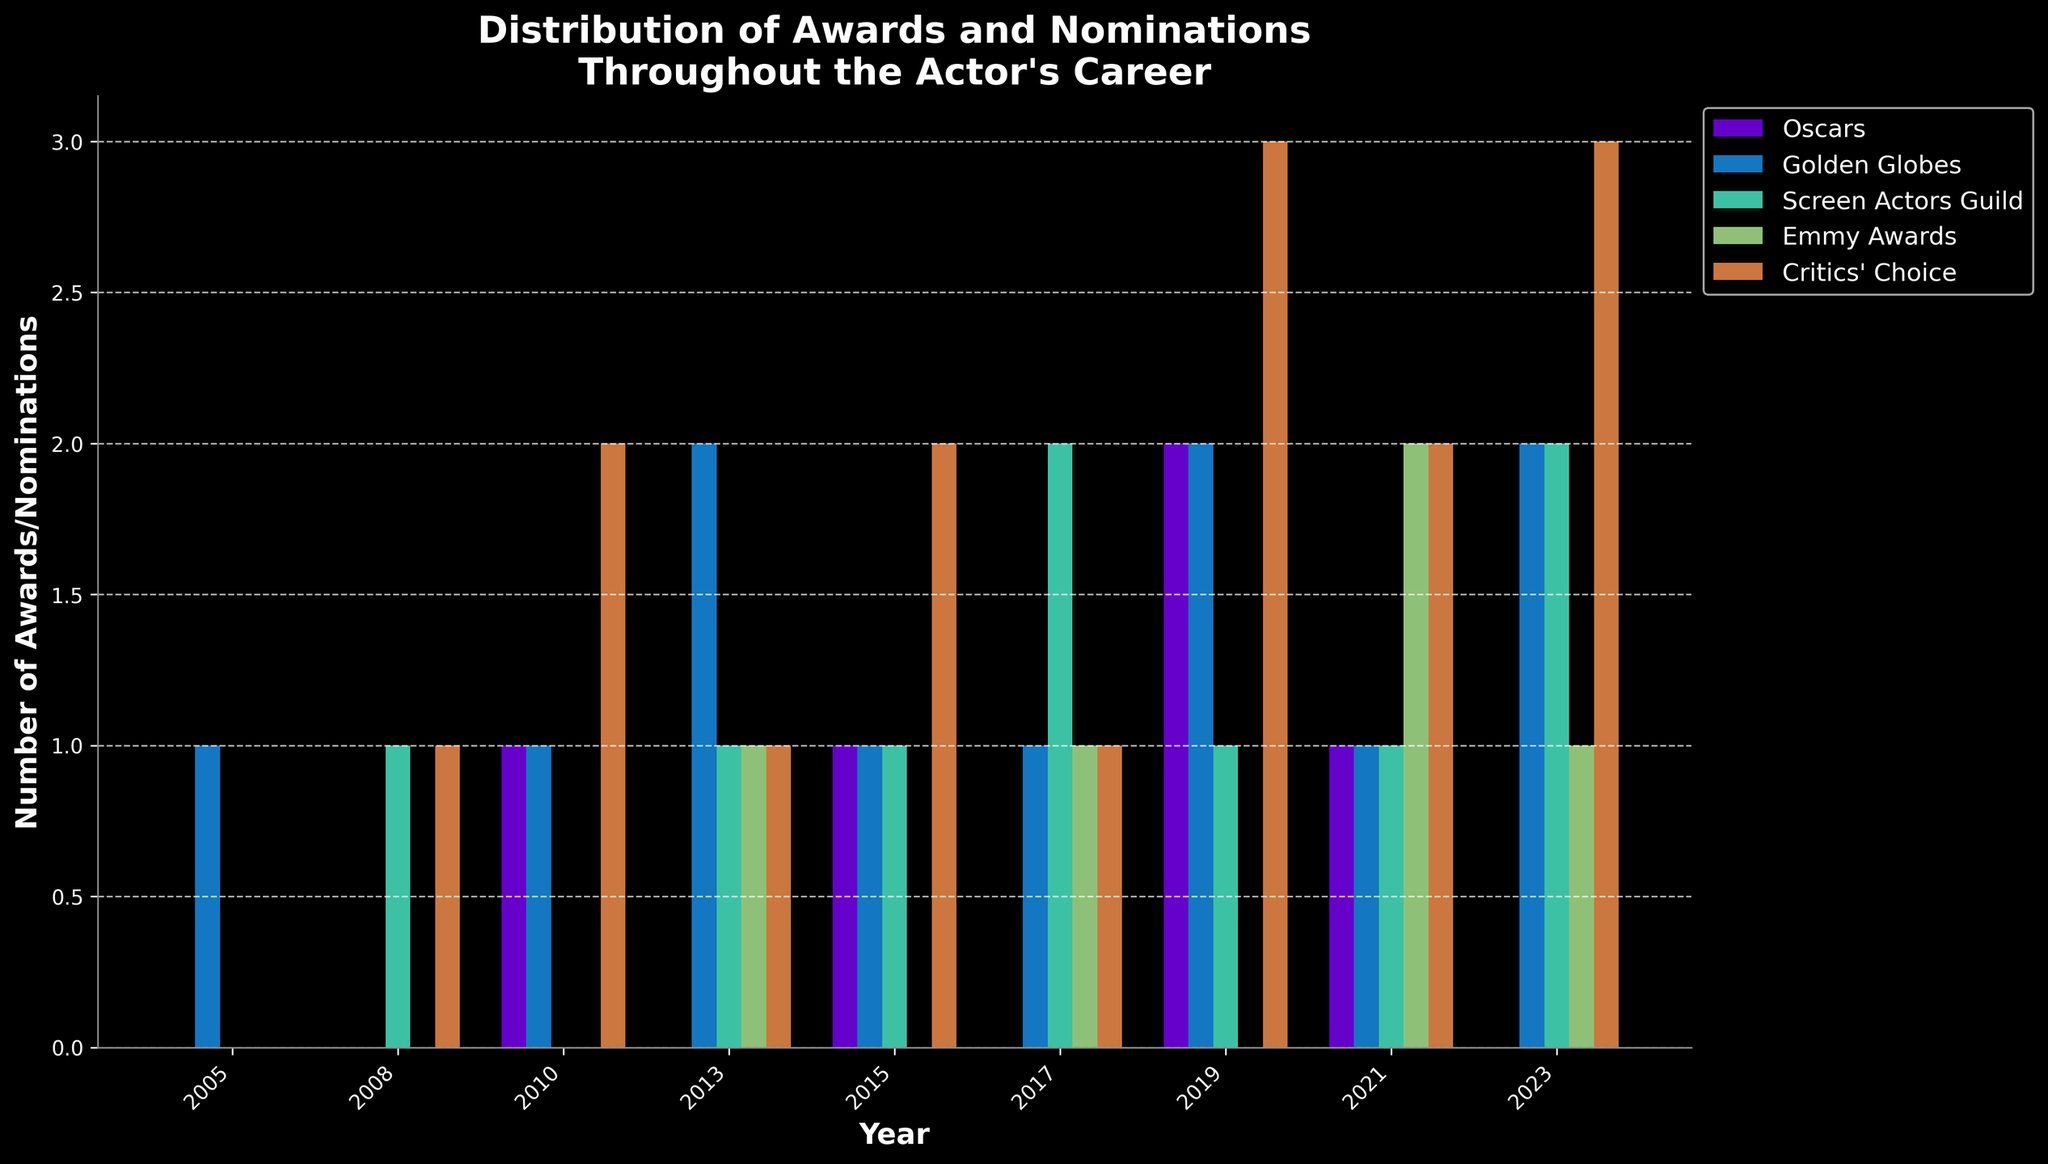what year did the actor receive the most Oscars? From the bar chart, the bars representing Oscars peak in 2019 with a height of 2, indicating that this is the year the actor received the most Oscars.
Answer: 2019 how many total awards and nominations did the actor receive in 2017? To find the total awards and nominations in 2017, add the height of all bars for 2017: Oscars (0), Golden Globes (1), Screen Actors Guild (2), Emmy Awards (1), Critics' Choice (1). This sums up to 5.
Answer: 5 which award category has the most consistent trend across all years? Observing the visual representation, the Golden Globes category has bars every year and appears consistently across the years.
Answer: Golden Globes what is the difference in the number of Critics' Choice awards between 2010 and 2019? From the bar chart, Critics' Choice in 2010 is 2, and in 2019 it is 3. The difference is 3 - 2 = 1.
Answer: 1 which year had the highest number of Emmy Awards? By looking at the height of the Emmy Awards bars, 2021 has the tallest bar with a value of 2.
Answer: 2021 how many Golden Globes and Screen Actors Guild awards were received in 2023 combined? Adding the bars for Golden Globes (2) and Screen Actors Guild (2) in 2023, the total is 2 + 2 = 4.
Answer: 4 in which year did the actor receive an equal number of Oscars and Golden Globes awards? In 2010, both the Oscars and Golden Globes bars represent the same height value of 1, indicating they received an equal number of these awards that year.
Answer: 2010 compare the total number of awards received in 2015 versus 2017. Which year had more awards? Adding up the awards in 2015 (Oscars: 1, Golden Globes: 1, Screen Actors Guild: 1, Emmy Awards: 0, Critics' Choice: 2) sums to 5. In 2017 (Oscars: 0, Golden Globes: 1, Screen Actors Guild: 2, Emmy Awards: 1, Critics' Choice: 1) sums to 5. Both years had the same total number of awards.
Answer: Both years had 5 awards what is the average number of Emmy Awards received across all the years? The total number of Emmy Awards over all the years is 5 (0 + 0 + 0 + 1 + 0 + 1 + 0 + 2 + 1), and there are 9 years in total, so the average is 5/9 ≈ 0.56.
Answer: 0.56 